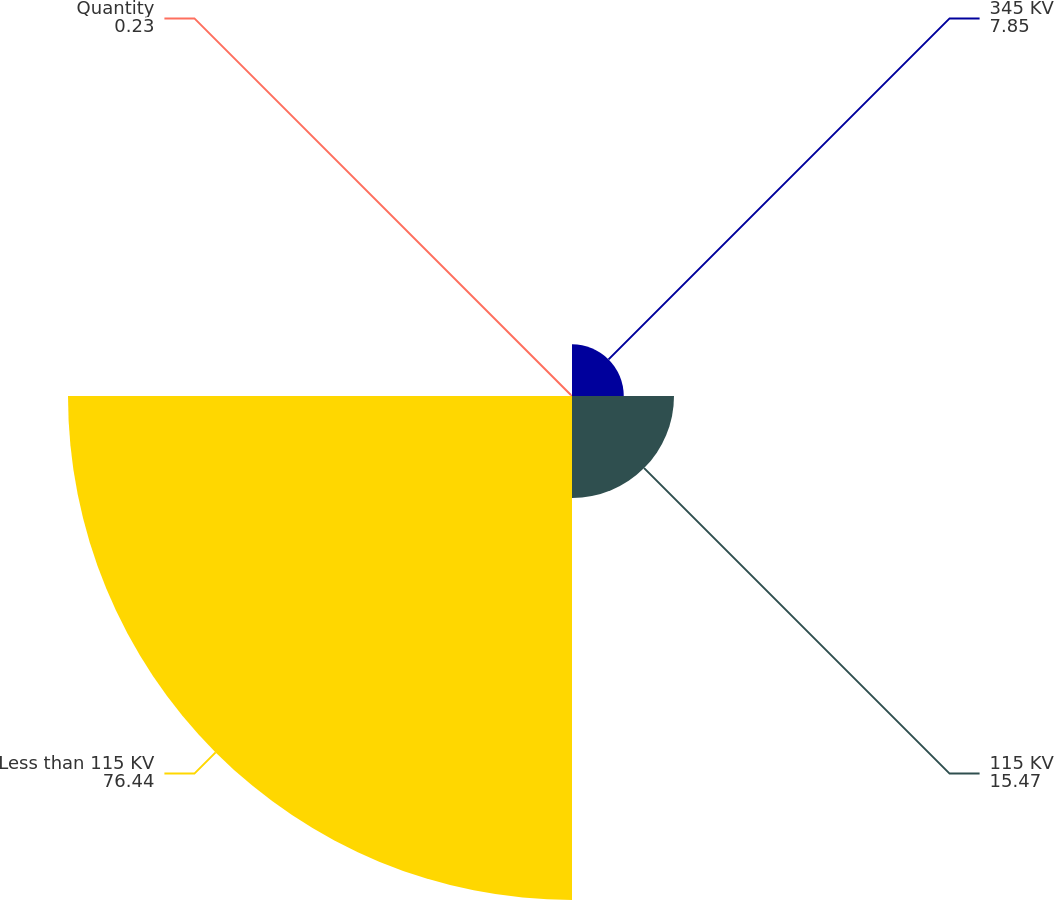Convert chart to OTSL. <chart><loc_0><loc_0><loc_500><loc_500><pie_chart><fcel>345 KV<fcel>115 KV<fcel>Less than 115 KV<fcel>Quantity<nl><fcel>7.85%<fcel>15.47%<fcel>76.44%<fcel>0.23%<nl></chart> 